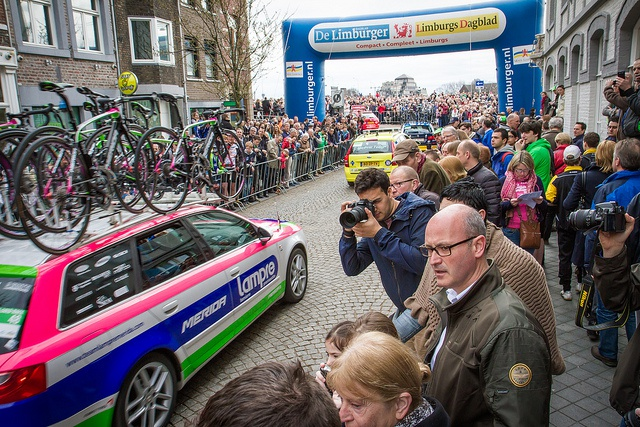Describe the objects in this image and their specific colors. I can see car in maroon, black, darkgray, navy, and gray tones, people in maroon, black, gray, and brown tones, bicycle in maroon, black, gray, darkgray, and lightgray tones, people in maroon, gray, and black tones, and people in maroon, black, navy, gray, and brown tones in this image. 